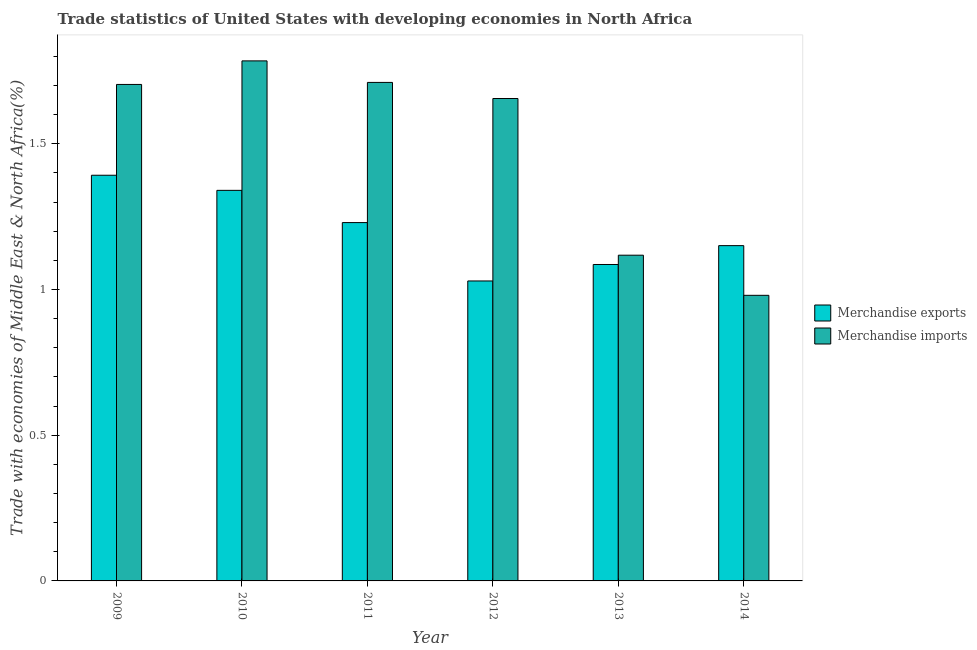Are the number of bars on each tick of the X-axis equal?
Offer a terse response. Yes. How many bars are there on the 6th tick from the left?
Provide a succinct answer. 2. In how many cases, is the number of bars for a given year not equal to the number of legend labels?
Ensure brevity in your answer.  0. What is the merchandise imports in 2011?
Provide a succinct answer. 1.71. Across all years, what is the maximum merchandise exports?
Your answer should be very brief. 1.39. Across all years, what is the minimum merchandise exports?
Your answer should be very brief. 1.03. In which year was the merchandise imports maximum?
Ensure brevity in your answer.  2010. What is the total merchandise exports in the graph?
Your response must be concise. 7.23. What is the difference between the merchandise imports in 2011 and that in 2014?
Keep it short and to the point. 0.73. What is the difference between the merchandise exports in 2013 and the merchandise imports in 2012?
Provide a short and direct response. 0.06. What is the average merchandise imports per year?
Provide a succinct answer. 1.49. What is the ratio of the merchandise exports in 2010 to that in 2013?
Your response must be concise. 1.23. Is the merchandise exports in 2009 less than that in 2012?
Give a very brief answer. No. Is the difference between the merchandise exports in 2009 and 2010 greater than the difference between the merchandise imports in 2009 and 2010?
Ensure brevity in your answer.  No. What is the difference between the highest and the second highest merchandise imports?
Make the answer very short. 0.07. What is the difference between the highest and the lowest merchandise exports?
Your answer should be compact. 0.36. In how many years, is the merchandise exports greater than the average merchandise exports taken over all years?
Offer a terse response. 3. What does the 1st bar from the left in 2010 represents?
Your answer should be very brief. Merchandise exports. What does the 2nd bar from the right in 2013 represents?
Your response must be concise. Merchandise exports. How many bars are there?
Keep it short and to the point. 12. Are all the bars in the graph horizontal?
Your answer should be very brief. No. Are the values on the major ticks of Y-axis written in scientific E-notation?
Offer a very short reply. No. How are the legend labels stacked?
Give a very brief answer. Vertical. What is the title of the graph?
Make the answer very short. Trade statistics of United States with developing economies in North Africa. What is the label or title of the X-axis?
Keep it short and to the point. Year. What is the label or title of the Y-axis?
Your response must be concise. Trade with economies of Middle East & North Africa(%). What is the Trade with economies of Middle East & North Africa(%) of Merchandise exports in 2009?
Give a very brief answer. 1.39. What is the Trade with economies of Middle East & North Africa(%) in Merchandise imports in 2009?
Ensure brevity in your answer.  1.7. What is the Trade with economies of Middle East & North Africa(%) of Merchandise exports in 2010?
Offer a terse response. 1.34. What is the Trade with economies of Middle East & North Africa(%) in Merchandise imports in 2010?
Offer a terse response. 1.78. What is the Trade with economies of Middle East & North Africa(%) of Merchandise exports in 2011?
Make the answer very short. 1.23. What is the Trade with economies of Middle East & North Africa(%) in Merchandise imports in 2011?
Your answer should be very brief. 1.71. What is the Trade with economies of Middle East & North Africa(%) of Merchandise exports in 2012?
Give a very brief answer. 1.03. What is the Trade with economies of Middle East & North Africa(%) of Merchandise imports in 2012?
Offer a very short reply. 1.66. What is the Trade with economies of Middle East & North Africa(%) of Merchandise exports in 2013?
Your response must be concise. 1.09. What is the Trade with economies of Middle East & North Africa(%) of Merchandise imports in 2013?
Give a very brief answer. 1.12. What is the Trade with economies of Middle East & North Africa(%) in Merchandise exports in 2014?
Keep it short and to the point. 1.15. What is the Trade with economies of Middle East & North Africa(%) of Merchandise imports in 2014?
Ensure brevity in your answer.  0.98. Across all years, what is the maximum Trade with economies of Middle East & North Africa(%) in Merchandise exports?
Offer a terse response. 1.39. Across all years, what is the maximum Trade with economies of Middle East & North Africa(%) of Merchandise imports?
Provide a short and direct response. 1.78. Across all years, what is the minimum Trade with economies of Middle East & North Africa(%) of Merchandise exports?
Keep it short and to the point. 1.03. Across all years, what is the minimum Trade with economies of Middle East & North Africa(%) in Merchandise imports?
Give a very brief answer. 0.98. What is the total Trade with economies of Middle East & North Africa(%) of Merchandise exports in the graph?
Your answer should be very brief. 7.23. What is the total Trade with economies of Middle East & North Africa(%) of Merchandise imports in the graph?
Make the answer very short. 8.95. What is the difference between the Trade with economies of Middle East & North Africa(%) of Merchandise exports in 2009 and that in 2010?
Offer a terse response. 0.05. What is the difference between the Trade with economies of Middle East & North Africa(%) in Merchandise imports in 2009 and that in 2010?
Your answer should be very brief. -0.08. What is the difference between the Trade with economies of Middle East & North Africa(%) in Merchandise exports in 2009 and that in 2011?
Offer a terse response. 0.16. What is the difference between the Trade with economies of Middle East & North Africa(%) of Merchandise imports in 2009 and that in 2011?
Offer a very short reply. -0.01. What is the difference between the Trade with economies of Middle East & North Africa(%) in Merchandise exports in 2009 and that in 2012?
Your response must be concise. 0.36. What is the difference between the Trade with economies of Middle East & North Africa(%) of Merchandise imports in 2009 and that in 2012?
Give a very brief answer. 0.05. What is the difference between the Trade with economies of Middle East & North Africa(%) in Merchandise exports in 2009 and that in 2013?
Your answer should be very brief. 0.31. What is the difference between the Trade with economies of Middle East & North Africa(%) in Merchandise imports in 2009 and that in 2013?
Offer a very short reply. 0.59. What is the difference between the Trade with economies of Middle East & North Africa(%) of Merchandise exports in 2009 and that in 2014?
Offer a terse response. 0.24. What is the difference between the Trade with economies of Middle East & North Africa(%) in Merchandise imports in 2009 and that in 2014?
Offer a terse response. 0.72. What is the difference between the Trade with economies of Middle East & North Africa(%) in Merchandise exports in 2010 and that in 2011?
Keep it short and to the point. 0.11. What is the difference between the Trade with economies of Middle East & North Africa(%) of Merchandise imports in 2010 and that in 2011?
Your response must be concise. 0.07. What is the difference between the Trade with economies of Middle East & North Africa(%) in Merchandise exports in 2010 and that in 2012?
Provide a succinct answer. 0.31. What is the difference between the Trade with economies of Middle East & North Africa(%) of Merchandise imports in 2010 and that in 2012?
Your response must be concise. 0.13. What is the difference between the Trade with economies of Middle East & North Africa(%) of Merchandise exports in 2010 and that in 2013?
Keep it short and to the point. 0.25. What is the difference between the Trade with economies of Middle East & North Africa(%) in Merchandise imports in 2010 and that in 2013?
Give a very brief answer. 0.67. What is the difference between the Trade with economies of Middle East & North Africa(%) of Merchandise exports in 2010 and that in 2014?
Make the answer very short. 0.19. What is the difference between the Trade with economies of Middle East & North Africa(%) in Merchandise imports in 2010 and that in 2014?
Provide a short and direct response. 0.8. What is the difference between the Trade with economies of Middle East & North Africa(%) of Merchandise exports in 2011 and that in 2012?
Keep it short and to the point. 0.2. What is the difference between the Trade with economies of Middle East & North Africa(%) in Merchandise imports in 2011 and that in 2012?
Your response must be concise. 0.06. What is the difference between the Trade with economies of Middle East & North Africa(%) of Merchandise exports in 2011 and that in 2013?
Keep it short and to the point. 0.14. What is the difference between the Trade with economies of Middle East & North Africa(%) of Merchandise imports in 2011 and that in 2013?
Ensure brevity in your answer.  0.59. What is the difference between the Trade with economies of Middle East & North Africa(%) of Merchandise exports in 2011 and that in 2014?
Provide a short and direct response. 0.08. What is the difference between the Trade with economies of Middle East & North Africa(%) in Merchandise imports in 2011 and that in 2014?
Your answer should be compact. 0.73. What is the difference between the Trade with economies of Middle East & North Africa(%) of Merchandise exports in 2012 and that in 2013?
Your answer should be compact. -0.06. What is the difference between the Trade with economies of Middle East & North Africa(%) in Merchandise imports in 2012 and that in 2013?
Your response must be concise. 0.54. What is the difference between the Trade with economies of Middle East & North Africa(%) of Merchandise exports in 2012 and that in 2014?
Your answer should be compact. -0.12. What is the difference between the Trade with economies of Middle East & North Africa(%) of Merchandise imports in 2012 and that in 2014?
Your answer should be very brief. 0.68. What is the difference between the Trade with economies of Middle East & North Africa(%) of Merchandise exports in 2013 and that in 2014?
Your answer should be very brief. -0.06. What is the difference between the Trade with economies of Middle East & North Africa(%) in Merchandise imports in 2013 and that in 2014?
Offer a terse response. 0.14. What is the difference between the Trade with economies of Middle East & North Africa(%) of Merchandise exports in 2009 and the Trade with economies of Middle East & North Africa(%) of Merchandise imports in 2010?
Your answer should be compact. -0.39. What is the difference between the Trade with economies of Middle East & North Africa(%) in Merchandise exports in 2009 and the Trade with economies of Middle East & North Africa(%) in Merchandise imports in 2011?
Offer a terse response. -0.32. What is the difference between the Trade with economies of Middle East & North Africa(%) of Merchandise exports in 2009 and the Trade with economies of Middle East & North Africa(%) of Merchandise imports in 2012?
Provide a succinct answer. -0.26. What is the difference between the Trade with economies of Middle East & North Africa(%) of Merchandise exports in 2009 and the Trade with economies of Middle East & North Africa(%) of Merchandise imports in 2013?
Make the answer very short. 0.27. What is the difference between the Trade with economies of Middle East & North Africa(%) in Merchandise exports in 2009 and the Trade with economies of Middle East & North Africa(%) in Merchandise imports in 2014?
Provide a succinct answer. 0.41. What is the difference between the Trade with economies of Middle East & North Africa(%) of Merchandise exports in 2010 and the Trade with economies of Middle East & North Africa(%) of Merchandise imports in 2011?
Give a very brief answer. -0.37. What is the difference between the Trade with economies of Middle East & North Africa(%) of Merchandise exports in 2010 and the Trade with economies of Middle East & North Africa(%) of Merchandise imports in 2012?
Your answer should be very brief. -0.32. What is the difference between the Trade with economies of Middle East & North Africa(%) of Merchandise exports in 2010 and the Trade with economies of Middle East & North Africa(%) of Merchandise imports in 2013?
Ensure brevity in your answer.  0.22. What is the difference between the Trade with economies of Middle East & North Africa(%) in Merchandise exports in 2010 and the Trade with economies of Middle East & North Africa(%) in Merchandise imports in 2014?
Your response must be concise. 0.36. What is the difference between the Trade with economies of Middle East & North Africa(%) of Merchandise exports in 2011 and the Trade with economies of Middle East & North Africa(%) of Merchandise imports in 2012?
Your answer should be compact. -0.43. What is the difference between the Trade with economies of Middle East & North Africa(%) of Merchandise exports in 2011 and the Trade with economies of Middle East & North Africa(%) of Merchandise imports in 2013?
Give a very brief answer. 0.11. What is the difference between the Trade with economies of Middle East & North Africa(%) in Merchandise exports in 2011 and the Trade with economies of Middle East & North Africa(%) in Merchandise imports in 2014?
Keep it short and to the point. 0.25. What is the difference between the Trade with economies of Middle East & North Africa(%) of Merchandise exports in 2012 and the Trade with economies of Middle East & North Africa(%) of Merchandise imports in 2013?
Ensure brevity in your answer.  -0.09. What is the difference between the Trade with economies of Middle East & North Africa(%) of Merchandise exports in 2012 and the Trade with economies of Middle East & North Africa(%) of Merchandise imports in 2014?
Offer a very short reply. 0.05. What is the difference between the Trade with economies of Middle East & North Africa(%) of Merchandise exports in 2013 and the Trade with economies of Middle East & North Africa(%) of Merchandise imports in 2014?
Offer a very short reply. 0.11. What is the average Trade with economies of Middle East & North Africa(%) of Merchandise exports per year?
Keep it short and to the point. 1.2. What is the average Trade with economies of Middle East & North Africa(%) of Merchandise imports per year?
Make the answer very short. 1.49. In the year 2009, what is the difference between the Trade with economies of Middle East & North Africa(%) in Merchandise exports and Trade with economies of Middle East & North Africa(%) in Merchandise imports?
Your answer should be very brief. -0.31. In the year 2010, what is the difference between the Trade with economies of Middle East & North Africa(%) in Merchandise exports and Trade with economies of Middle East & North Africa(%) in Merchandise imports?
Your response must be concise. -0.44. In the year 2011, what is the difference between the Trade with economies of Middle East & North Africa(%) in Merchandise exports and Trade with economies of Middle East & North Africa(%) in Merchandise imports?
Offer a terse response. -0.48. In the year 2012, what is the difference between the Trade with economies of Middle East & North Africa(%) of Merchandise exports and Trade with economies of Middle East & North Africa(%) of Merchandise imports?
Your answer should be compact. -0.63. In the year 2013, what is the difference between the Trade with economies of Middle East & North Africa(%) in Merchandise exports and Trade with economies of Middle East & North Africa(%) in Merchandise imports?
Provide a succinct answer. -0.03. In the year 2014, what is the difference between the Trade with economies of Middle East & North Africa(%) of Merchandise exports and Trade with economies of Middle East & North Africa(%) of Merchandise imports?
Offer a very short reply. 0.17. What is the ratio of the Trade with economies of Middle East & North Africa(%) in Merchandise exports in 2009 to that in 2010?
Your answer should be compact. 1.04. What is the ratio of the Trade with economies of Middle East & North Africa(%) of Merchandise imports in 2009 to that in 2010?
Provide a short and direct response. 0.95. What is the ratio of the Trade with economies of Middle East & North Africa(%) in Merchandise exports in 2009 to that in 2011?
Offer a terse response. 1.13. What is the ratio of the Trade with economies of Middle East & North Africa(%) of Merchandise imports in 2009 to that in 2011?
Your answer should be compact. 1. What is the ratio of the Trade with economies of Middle East & North Africa(%) of Merchandise exports in 2009 to that in 2012?
Provide a short and direct response. 1.35. What is the ratio of the Trade with economies of Middle East & North Africa(%) in Merchandise imports in 2009 to that in 2012?
Offer a terse response. 1.03. What is the ratio of the Trade with economies of Middle East & North Africa(%) in Merchandise exports in 2009 to that in 2013?
Provide a succinct answer. 1.28. What is the ratio of the Trade with economies of Middle East & North Africa(%) of Merchandise imports in 2009 to that in 2013?
Your response must be concise. 1.52. What is the ratio of the Trade with economies of Middle East & North Africa(%) of Merchandise exports in 2009 to that in 2014?
Provide a succinct answer. 1.21. What is the ratio of the Trade with economies of Middle East & North Africa(%) of Merchandise imports in 2009 to that in 2014?
Your answer should be very brief. 1.74. What is the ratio of the Trade with economies of Middle East & North Africa(%) of Merchandise exports in 2010 to that in 2011?
Ensure brevity in your answer.  1.09. What is the ratio of the Trade with economies of Middle East & North Africa(%) of Merchandise imports in 2010 to that in 2011?
Your response must be concise. 1.04. What is the ratio of the Trade with economies of Middle East & North Africa(%) in Merchandise exports in 2010 to that in 2012?
Offer a very short reply. 1.3. What is the ratio of the Trade with economies of Middle East & North Africa(%) of Merchandise imports in 2010 to that in 2012?
Provide a succinct answer. 1.08. What is the ratio of the Trade with economies of Middle East & North Africa(%) in Merchandise exports in 2010 to that in 2013?
Provide a succinct answer. 1.23. What is the ratio of the Trade with economies of Middle East & North Africa(%) of Merchandise imports in 2010 to that in 2013?
Provide a succinct answer. 1.6. What is the ratio of the Trade with economies of Middle East & North Africa(%) of Merchandise exports in 2010 to that in 2014?
Your response must be concise. 1.16. What is the ratio of the Trade with economies of Middle East & North Africa(%) in Merchandise imports in 2010 to that in 2014?
Your answer should be very brief. 1.82. What is the ratio of the Trade with economies of Middle East & North Africa(%) of Merchandise exports in 2011 to that in 2012?
Your answer should be very brief. 1.19. What is the ratio of the Trade with economies of Middle East & North Africa(%) of Merchandise imports in 2011 to that in 2012?
Keep it short and to the point. 1.03. What is the ratio of the Trade with economies of Middle East & North Africa(%) of Merchandise exports in 2011 to that in 2013?
Provide a succinct answer. 1.13. What is the ratio of the Trade with economies of Middle East & North Africa(%) in Merchandise imports in 2011 to that in 2013?
Your answer should be compact. 1.53. What is the ratio of the Trade with economies of Middle East & North Africa(%) of Merchandise exports in 2011 to that in 2014?
Your answer should be compact. 1.07. What is the ratio of the Trade with economies of Middle East & North Africa(%) in Merchandise imports in 2011 to that in 2014?
Offer a terse response. 1.75. What is the ratio of the Trade with economies of Middle East & North Africa(%) of Merchandise exports in 2012 to that in 2013?
Ensure brevity in your answer.  0.95. What is the ratio of the Trade with economies of Middle East & North Africa(%) of Merchandise imports in 2012 to that in 2013?
Provide a succinct answer. 1.48. What is the ratio of the Trade with economies of Middle East & North Africa(%) of Merchandise exports in 2012 to that in 2014?
Provide a succinct answer. 0.89. What is the ratio of the Trade with economies of Middle East & North Africa(%) of Merchandise imports in 2012 to that in 2014?
Ensure brevity in your answer.  1.69. What is the ratio of the Trade with economies of Middle East & North Africa(%) of Merchandise exports in 2013 to that in 2014?
Provide a succinct answer. 0.94. What is the ratio of the Trade with economies of Middle East & North Africa(%) in Merchandise imports in 2013 to that in 2014?
Your answer should be compact. 1.14. What is the difference between the highest and the second highest Trade with economies of Middle East & North Africa(%) in Merchandise exports?
Offer a very short reply. 0.05. What is the difference between the highest and the second highest Trade with economies of Middle East & North Africa(%) of Merchandise imports?
Give a very brief answer. 0.07. What is the difference between the highest and the lowest Trade with economies of Middle East & North Africa(%) in Merchandise exports?
Offer a terse response. 0.36. What is the difference between the highest and the lowest Trade with economies of Middle East & North Africa(%) of Merchandise imports?
Offer a terse response. 0.8. 